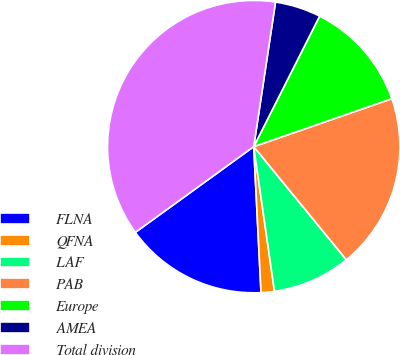Convert chart to OTSL. <chart><loc_0><loc_0><loc_500><loc_500><pie_chart><fcel>FLNA<fcel>QFNA<fcel>LAF<fcel>PAB<fcel>Europe<fcel>AMEA<fcel>Total division<nl><fcel>15.82%<fcel>1.47%<fcel>8.65%<fcel>19.41%<fcel>12.24%<fcel>5.06%<fcel>37.36%<nl></chart> 